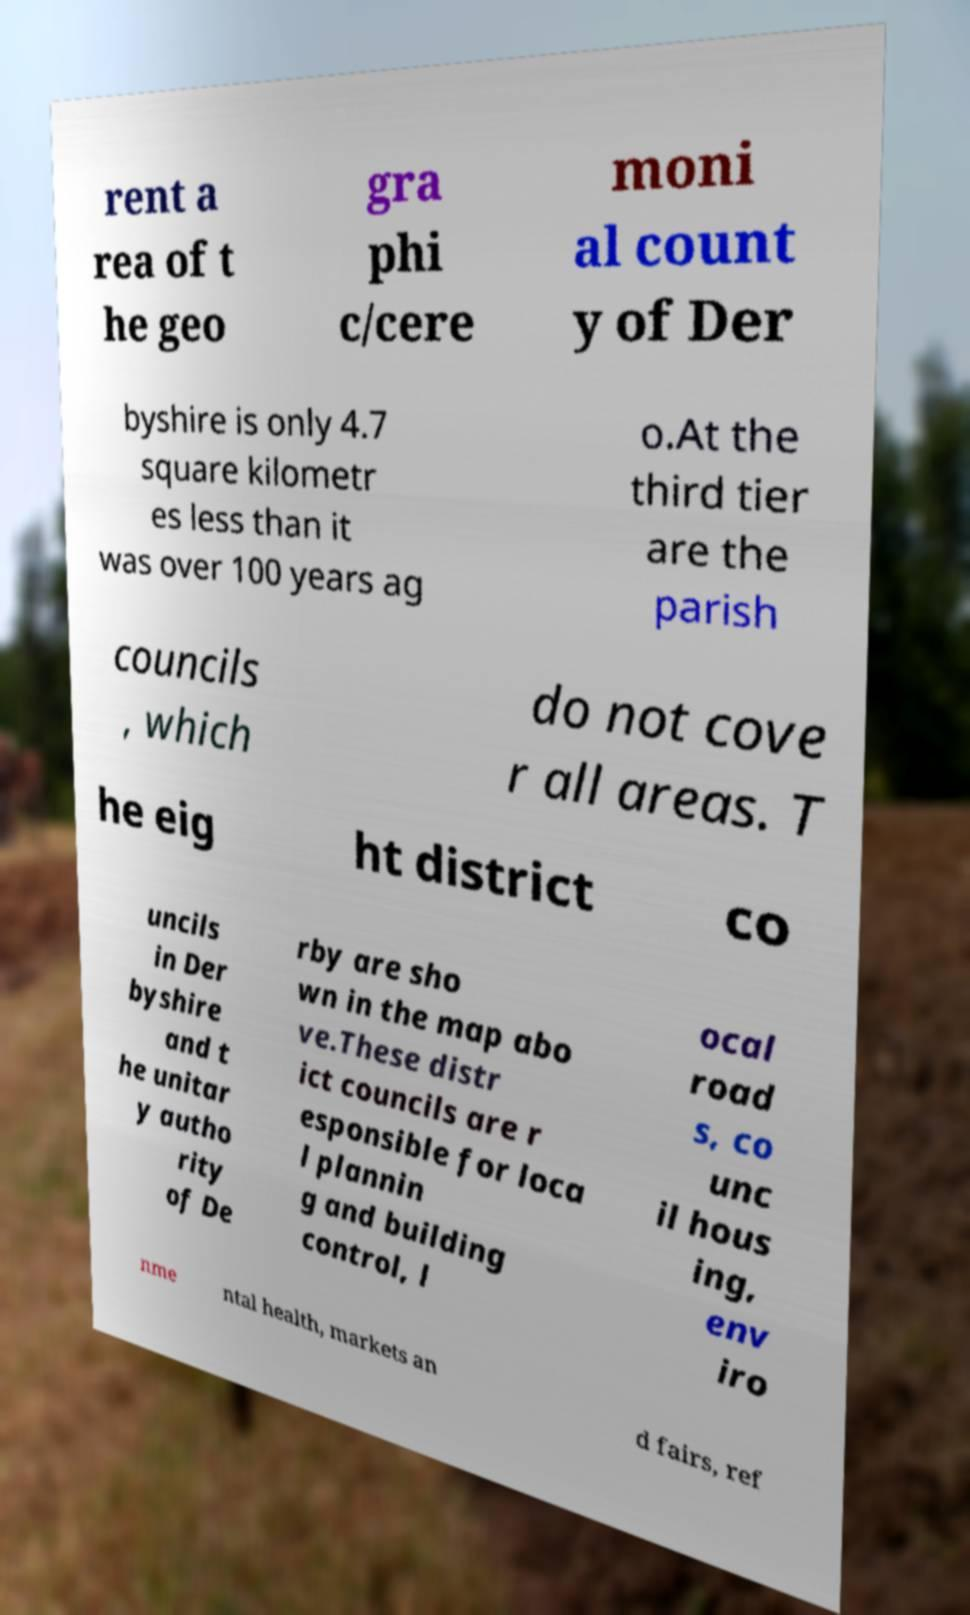Can you read and provide the text displayed in the image?This photo seems to have some interesting text. Can you extract and type it out for me? rent a rea of t he geo gra phi c/cere moni al count y of Der byshire is only 4.7 square kilometr es less than it was over 100 years ag o.At the third tier are the parish councils , which do not cove r all areas. T he eig ht district co uncils in Der byshire and t he unitar y autho rity of De rby are sho wn in the map abo ve.These distr ict councils are r esponsible for loca l plannin g and building control, l ocal road s, co unc il hous ing, env iro nme ntal health, markets an d fairs, ref 